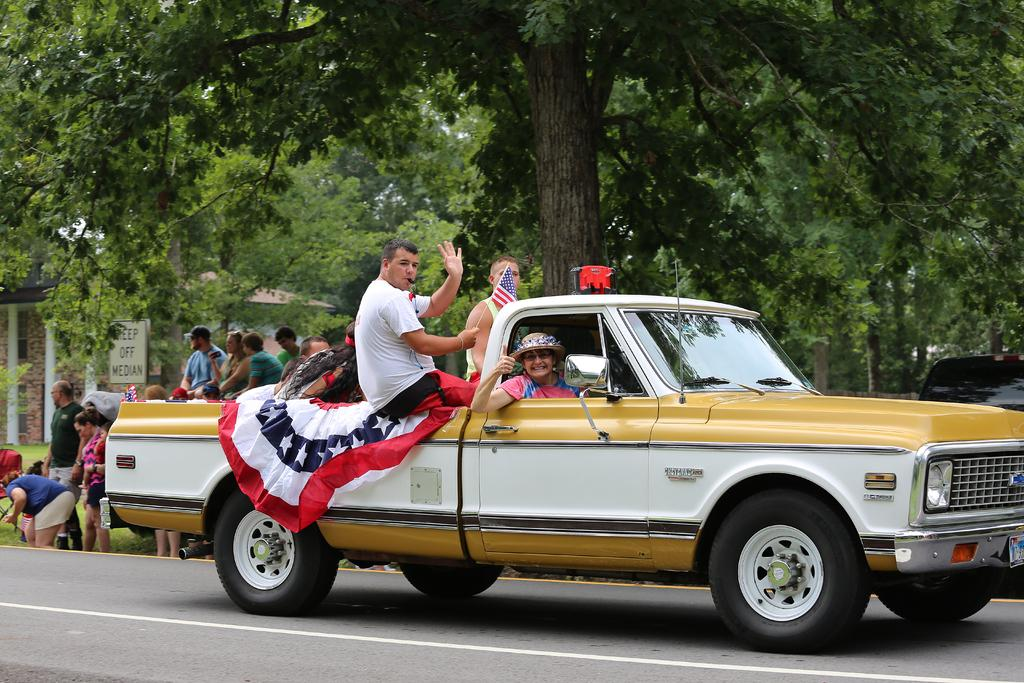What types of vehicles can be seen in the image? There are vehicles in the image, but the specific types are not mentioned. What is the primary surface in the image? There is a road in the image. What type of natural elements are present in the image? There are trees in the image. What type of man-made structure is visible in the image? There is a building in the image. What is the board in the image used for? The purpose of the board in the image is not mentioned. How many people are present in the image? There are people in the image, but the exact number is not specified. What objects can be seen in the image? There are objects in the image, but their specific types are not mentioned. What is the person holding a flag doing? One person is holding a flag in the image, but the context or purpose of this action is not mentioned. How many toes can be seen on the branch in the image? There is no branch or toes present in the image. What type of battle is taking place in the image? There is no battle present in the image. 